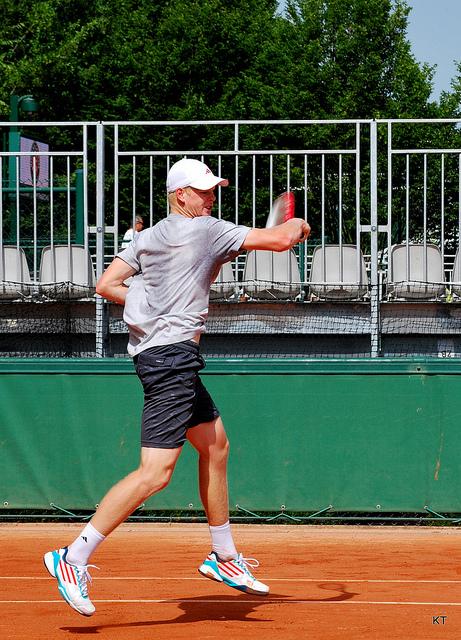What sport is being played?
Be succinct. Tennis. Who is watching?
Be succinct. No 1. What is on the ground under the player?
Keep it brief. Shadow. 